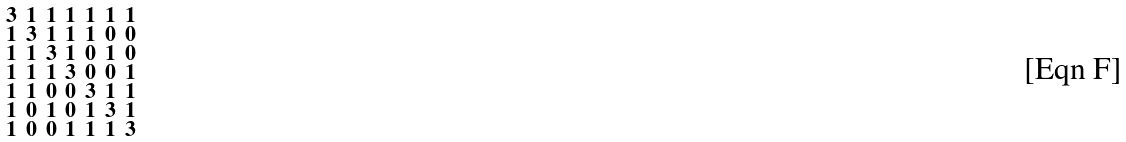<formula> <loc_0><loc_0><loc_500><loc_500>\begin{smallmatrix} 3 & 1 & 1 & 1 & 1 & 1 & 1 \\ 1 & 3 & 1 & 1 & 1 & 0 & 0 \\ 1 & 1 & 3 & 1 & 0 & 1 & 0 \\ 1 & 1 & 1 & 3 & 0 & 0 & 1 \\ 1 & 1 & 0 & 0 & 3 & 1 & 1 \\ 1 & 0 & 1 & 0 & 1 & 3 & 1 \\ 1 & 0 & 0 & 1 & 1 & 1 & 3 \end{smallmatrix}</formula> 